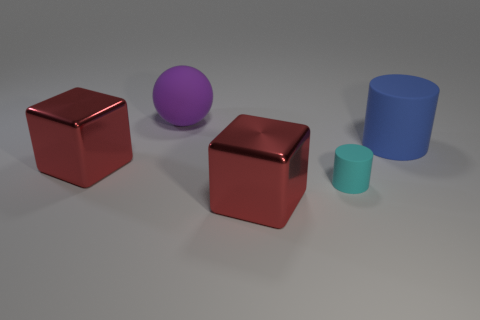Subtract all brown cylinders. Subtract all green balls. How many cylinders are left? 2 Add 2 blue rubber cylinders. How many objects exist? 7 Subtract all blocks. How many objects are left? 3 Add 1 red blocks. How many red blocks are left? 3 Add 1 small rubber things. How many small rubber things exist? 2 Subtract 1 purple spheres. How many objects are left? 4 Subtract all big gray metallic objects. Subtract all small cyan rubber cylinders. How many objects are left? 4 